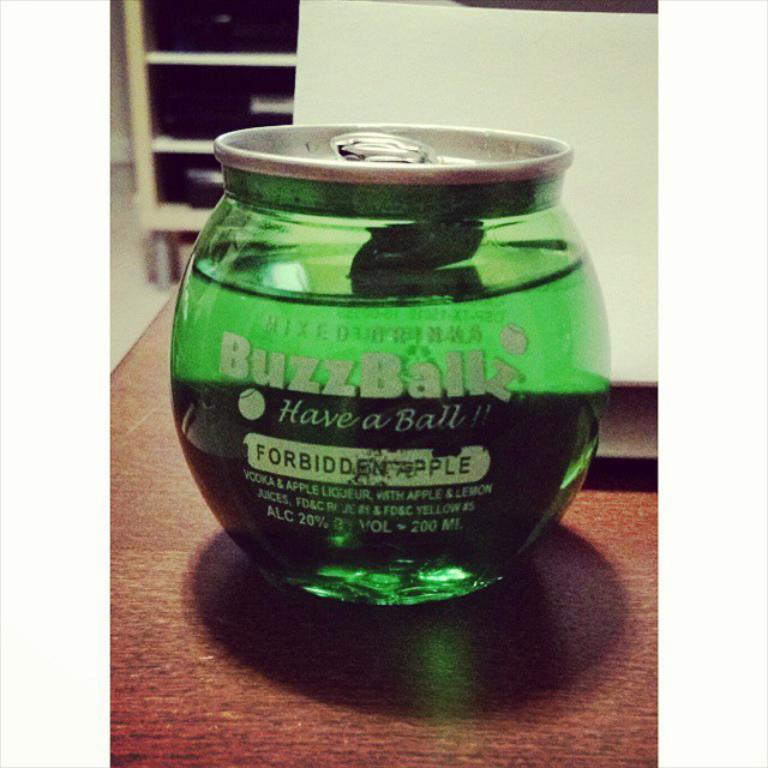What flavor is this drink?
Your answer should be very brief. Forbidden apple. What is the alcohol volume of this drink?
Your response must be concise. 20%. 